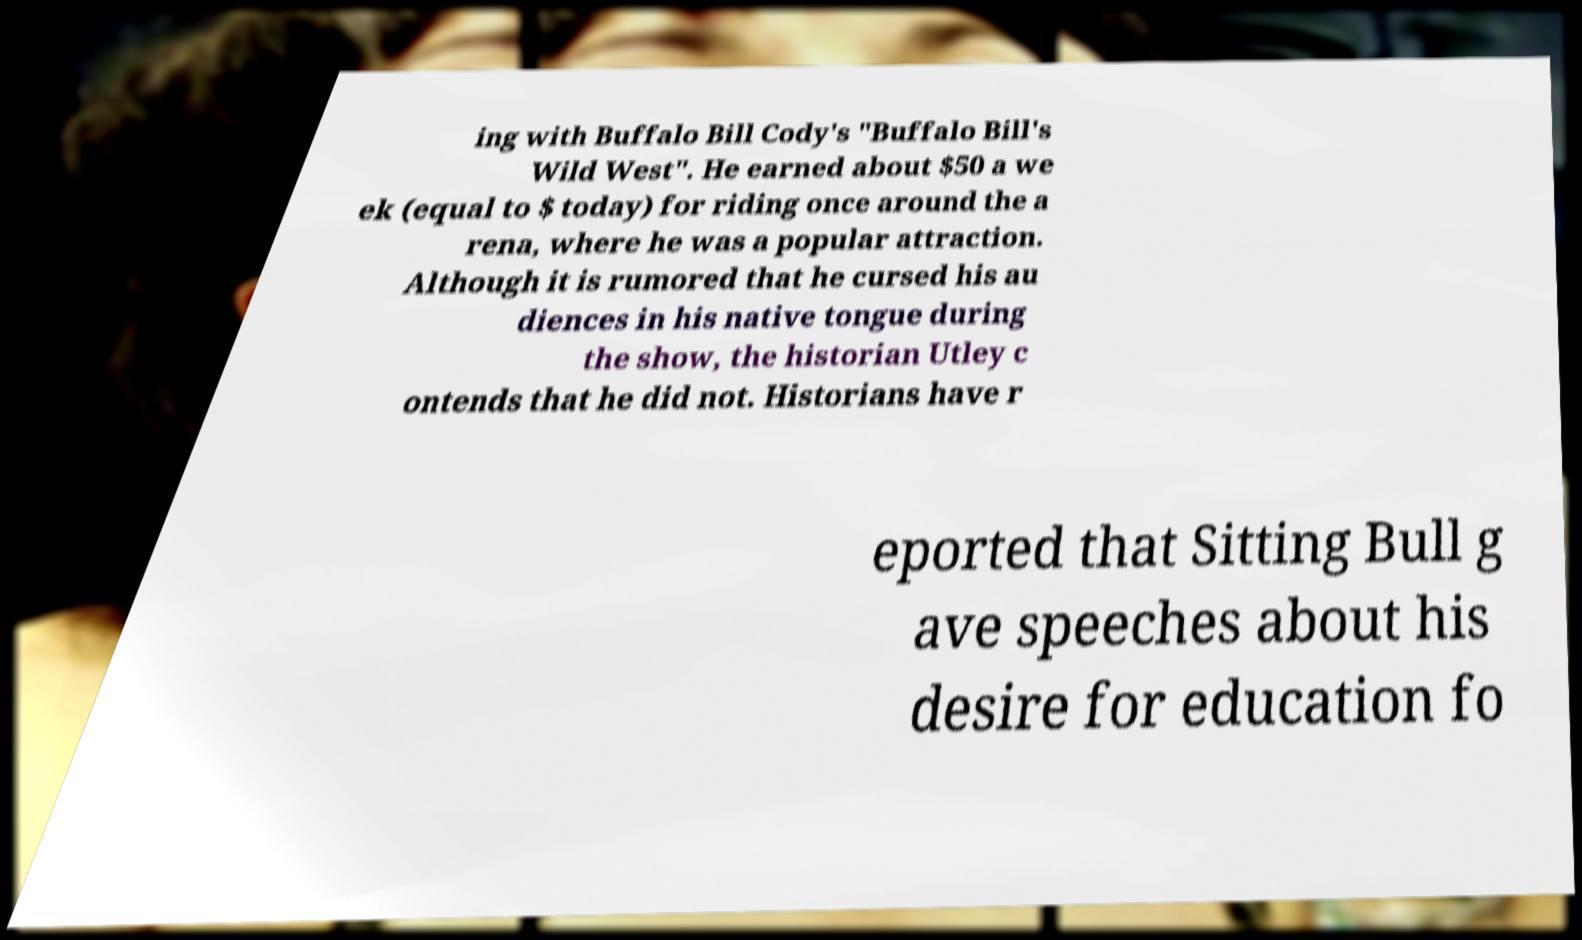Could you extract and type out the text from this image? ing with Buffalo Bill Cody's "Buffalo Bill's Wild West". He earned about $50 a we ek (equal to $ today) for riding once around the a rena, where he was a popular attraction. Although it is rumored that he cursed his au diences in his native tongue during the show, the historian Utley c ontends that he did not. Historians have r eported that Sitting Bull g ave speeches about his desire for education fo 